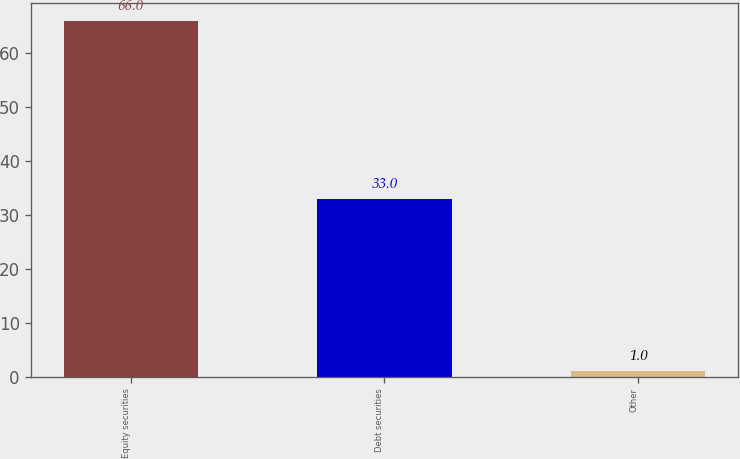Convert chart to OTSL. <chart><loc_0><loc_0><loc_500><loc_500><bar_chart><fcel>Equity securities<fcel>Debt securities<fcel>Other<nl><fcel>66<fcel>33<fcel>1<nl></chart> 